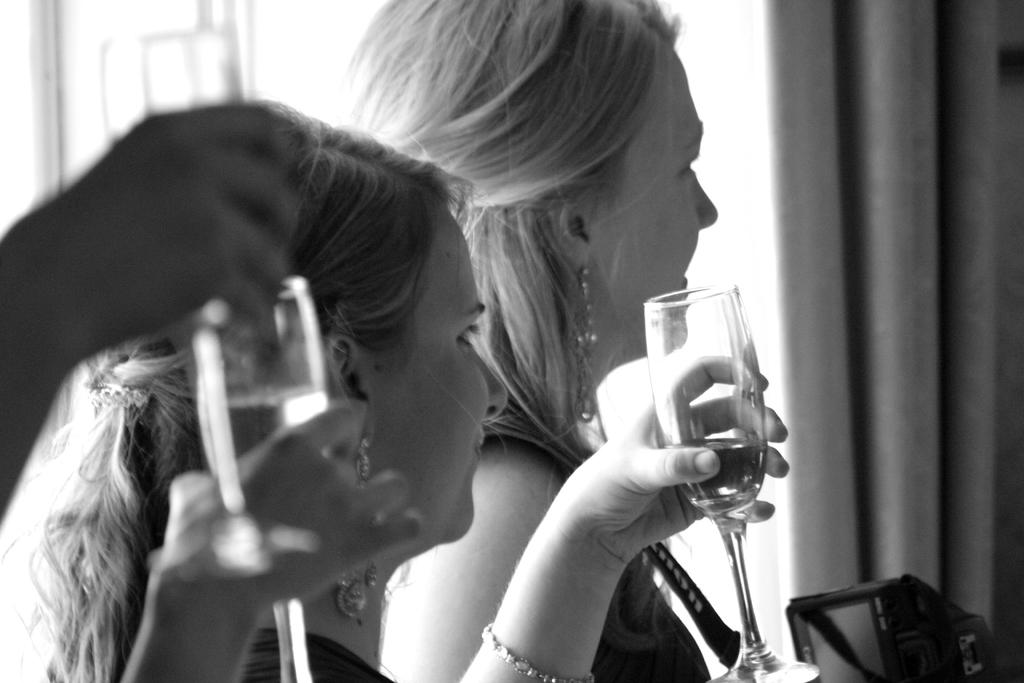How many people are in the image? There are two women in the image. What are the women holding in their hands? The women are holding wine glasses in their hands. What can be seen in the background of the image? There is a curtain in the background of the image. Can you see the moon in the image? No, the moon is not visible in the image. 